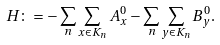<formula> <loc_0><loc_0><loc_500><loc_500>H \colon = - \sum _ { n } \sum _ { x \in K _ { n } } A _ { x } ^ { 0 } - \sum _ { n } \sum _ { y \in K _ { n } } B _ { y } ^ { 0 } .</formula> 